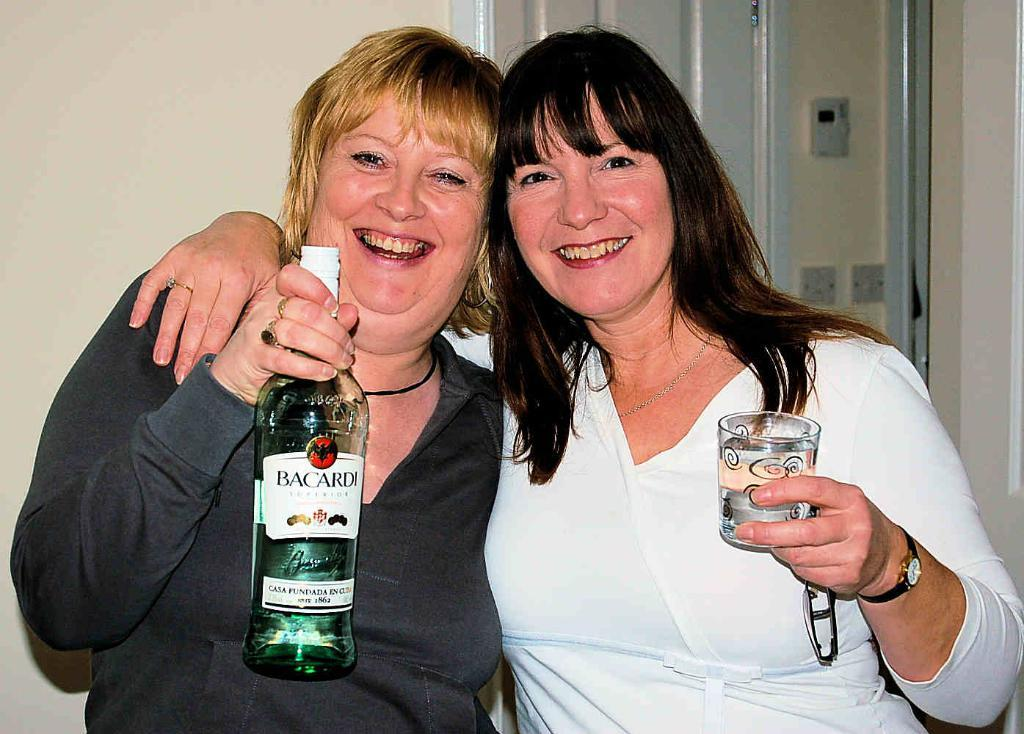How many people are in the image? There are two women in the image. What are the women doing in the image? The women are smiling and holding a wine bottle and a glass. What can be seen in the background of the image? There is a wall in the background of the image. What type of print can be seen on the bat in the image? There is no bat present in the image, and therefore no print can be observed. 